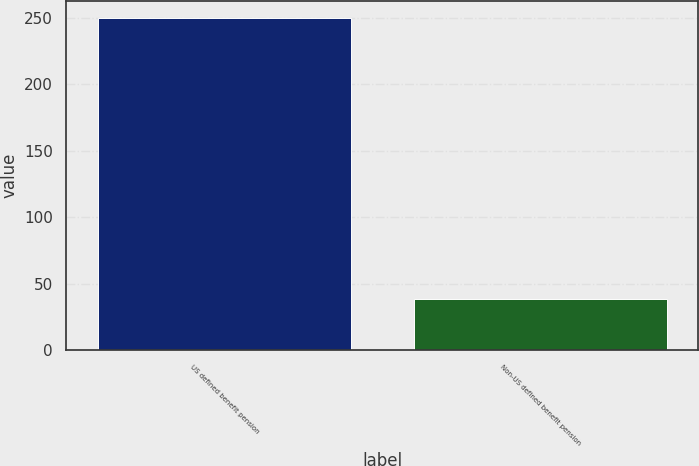<chart> <loc_0><loc_0><loc_500><loc_500><bar_chart><fcel>US defined benefit pension<fcel>Non-US defined benefit pension<nl><fcel>250<fcel>39<nl></chart> 